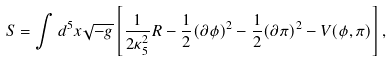<formula> <loc_0><loc_0><loc_500><loc_500>S = \int d ^ { 5 } x \sqrt { - g } \left [ \frac { 1 } { 2 \kappa _ { 5 } ^ { 2 } } R - \frac { 1 } { 2 } ( \partial \phi ) ^ { 2 } - \frac { 1 } { 2 } ( \partial \pi ) ^ { 2 } - V ( \phi , \pi ) \right ] ,</formula> 